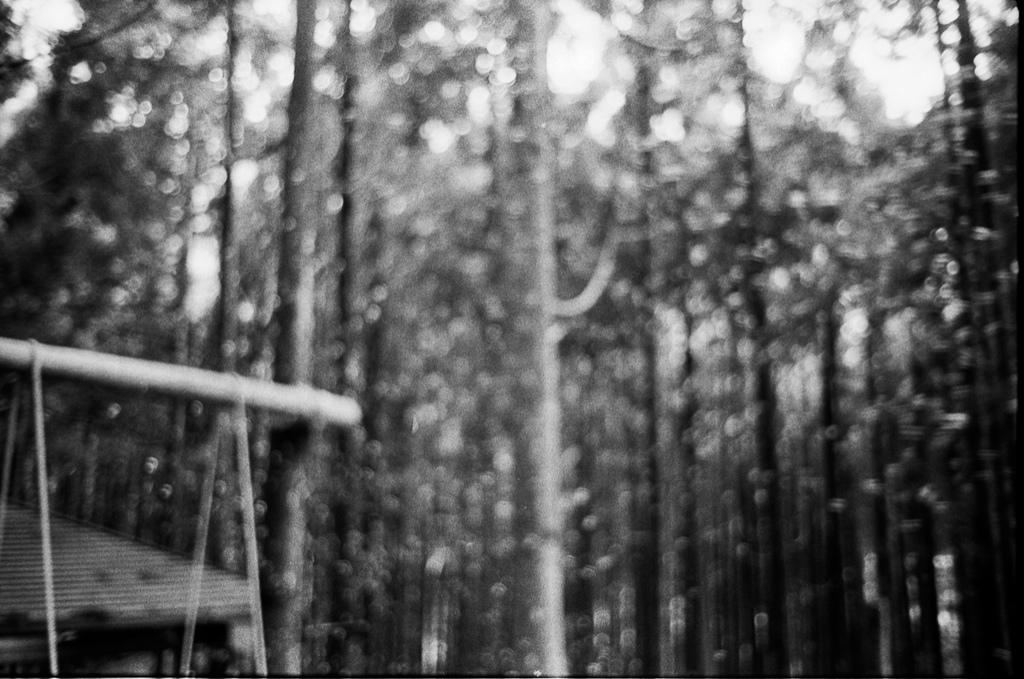What type of vegetation is present in the image? There are trees in the image. What object can be seen on the left side of the image? There is a wooden pole on the left side of the image. Where is the house located in the image? There appears to be a house at the bottom left corner of the image. How does the line of comfort affect the test in the image? There is no line or test present in the image, so this question cannot be answered. 